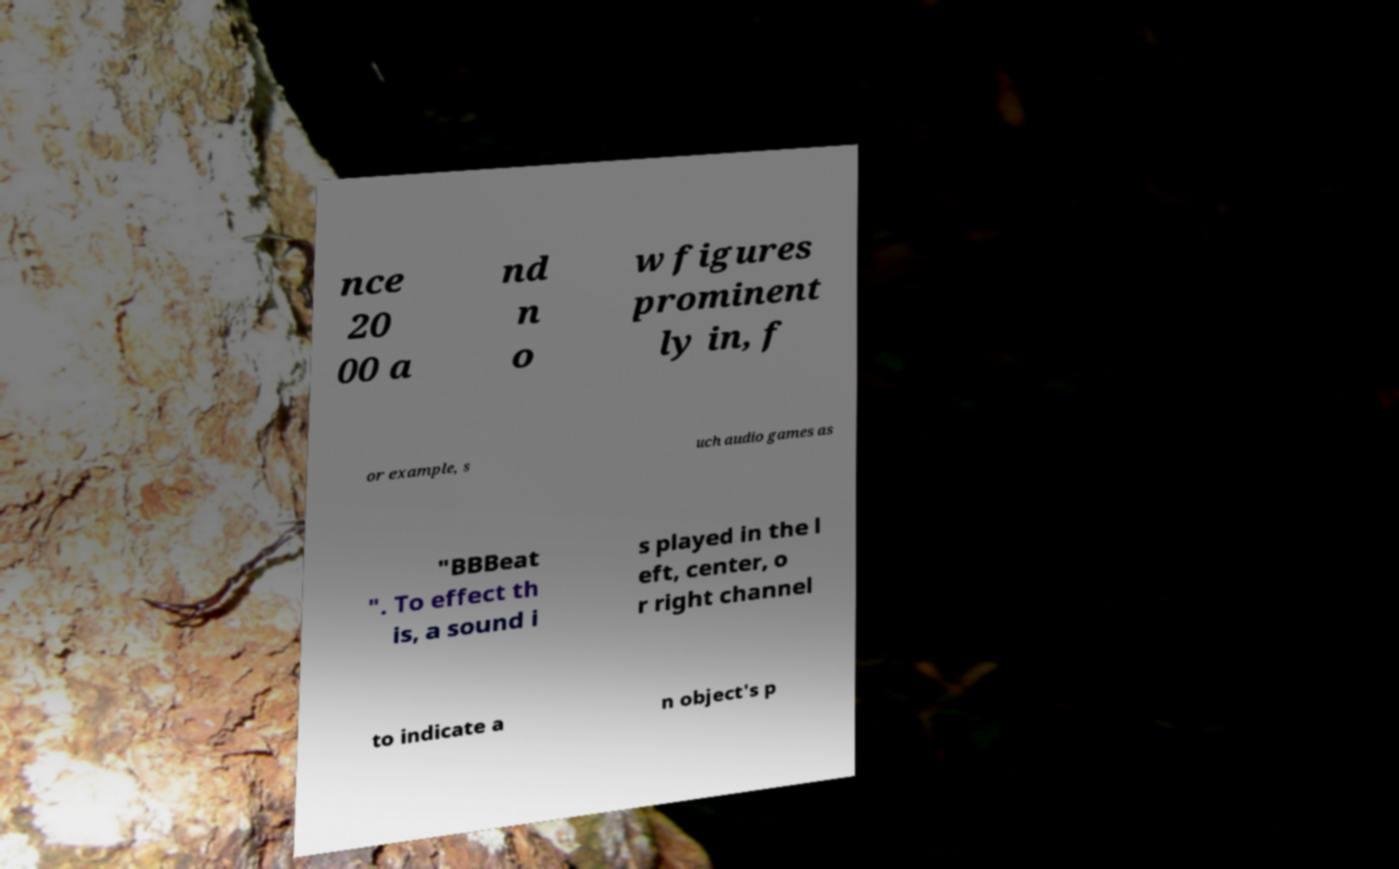What messages or text are displayed in this image? I need them in a readable, typed format. nce 20 00 a nd n o w figures prominent ly in, f or example, s uch audio games as "BBBeat ". To effect th is, a sound i s played in the l eft, center, o r right channel to indicate a n object's p 